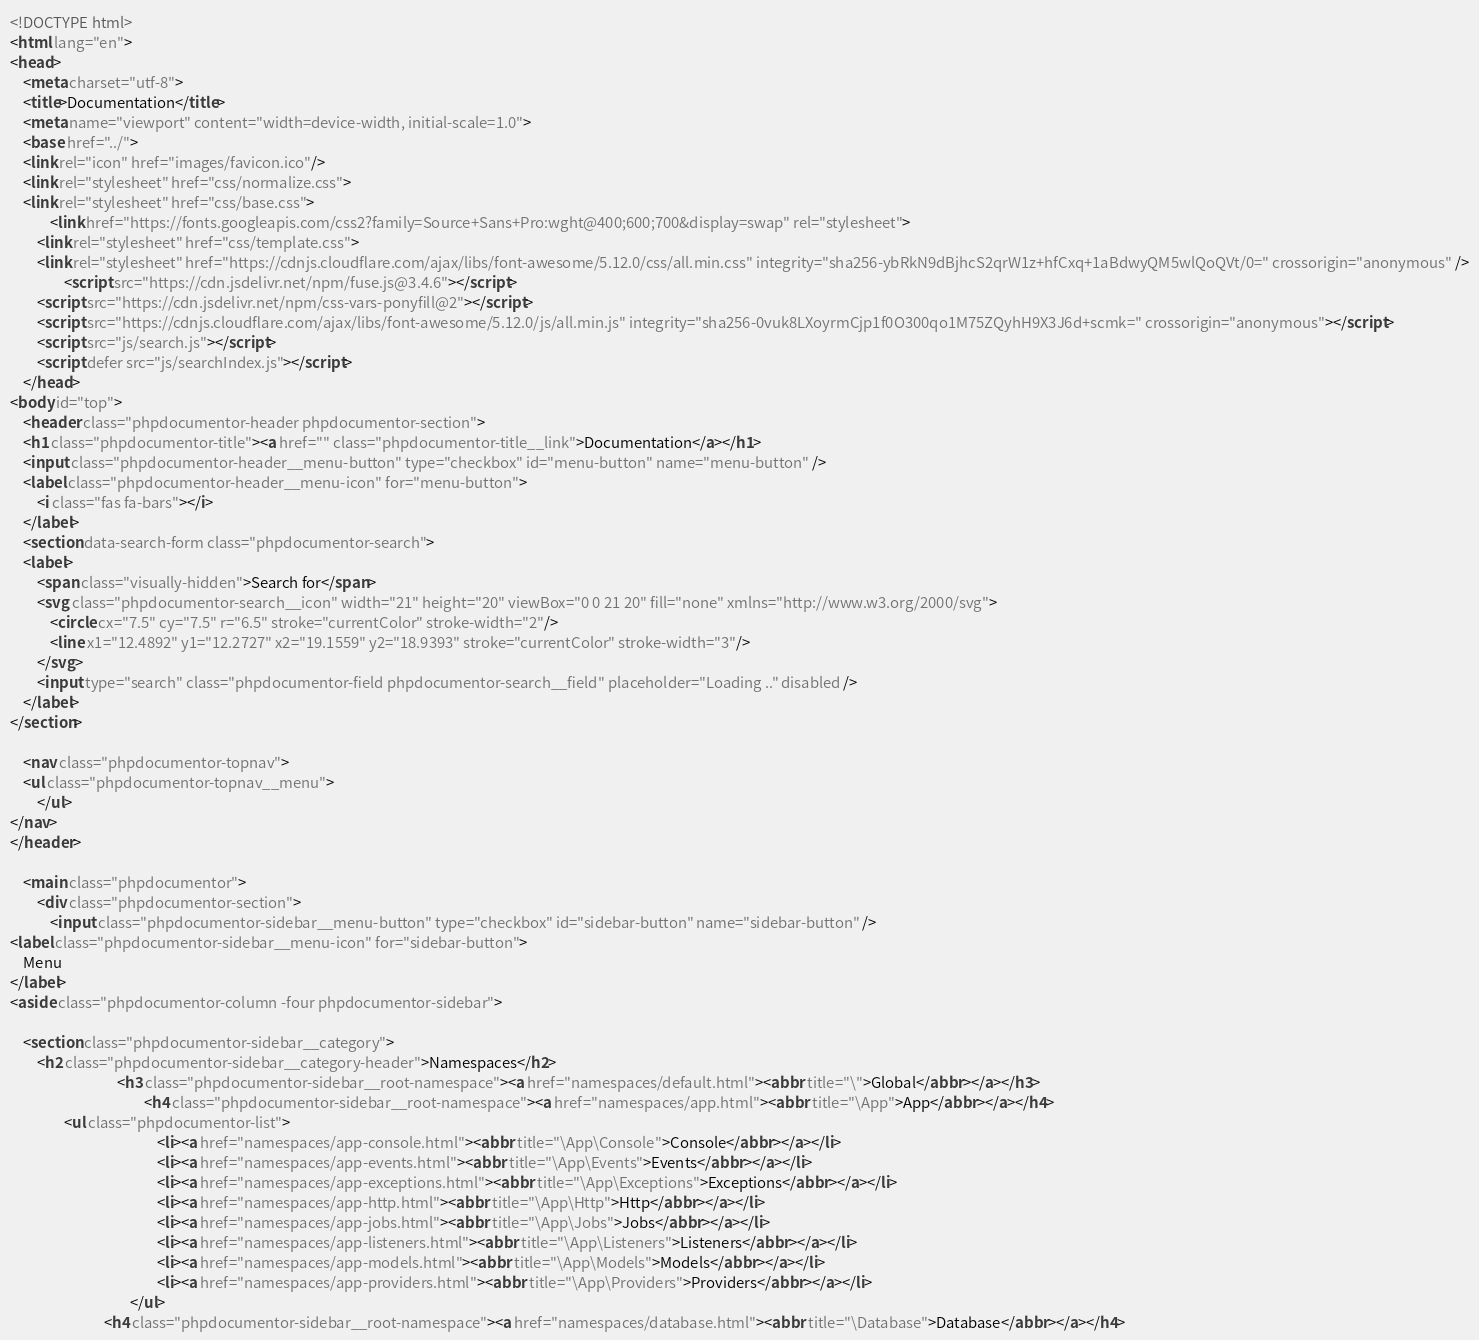Convert code to text. <code><loc_0><loc_0><loc_500><loc_500><_HTML_><!DOCTYPE html>
<html lang="en">
<head>
    <meta charset="utf-8">
    <title>Documentation</title>
    <meta name="viewport" content="width=device-width, initial-scale=1.0">
    <base href="../">
    <link rel="icon" href="images/favicon.ico"/>
    <link rel="stylesheet" href="css/normalize.css">
    <link rel="stylesheet" href="css/base.css">
            <link href="https://fonts.googleapis.com/css2?family=Source+Sans+Pro:wght@400;600;700&display=swap" rel="stylesheet">
        <link rel="stylesheet" href="css/template.css">
        <link rel="stylesheet" href="https://cdnjs.cloudflare.com/ajax/libs/font-awesome/5.12.0/css/all.min.css" integrity="sha256-ybRkN9dBjhcS2qrW1z+hfCxq+1aBdwyQM5wlQoQVt/0=" crossorigin="anonymous" />
                <script src="https://cdn.jsdelivr.net/npm/fuse.js@3.4.6"></script>
        <script src="https://cdn.jsdelivr.net/npm/css-vars-ponyfill@2"></script>
        <script src="https://cdnjs.cloudflare.com/ajax/libs/font-awesome/5.12.0/js/all.min.js" integrity="sha256-0vuk8LXoyrmCjp1f0O300qo1M75ZQyhH9X3J6d+scmk=" crossorigin="anonymous"></script>
        <script src="js/search.js"></script>
        <script defer src="js/searchIndex.js"></script>
    </head>
<body id="top">
    <header class="phpdocumentor-header phpdocumentor-section">
    <h1 class="phpdocumentor-title"><a href="" class="phpdocumentor-title__link">Documentation</a></h1>
    <input class="phpdocumentor-header__menu-button" type="checkbox" id="menu-button" name="menu-button" />
    <label class="phpdocumentor-header__menu-icon" for="menu-button">
        <i class="fas fa-bars"></i>
    </label>
    <section data-search-form class="phpdocumentor-search">
    <label>
        <span class="visually-hidden">Search for</span>
        <svg class="phpdocumentor-search__icon" width="21" height="20" viewBox="0 0 21 20" fill="none" xmlns="http://www.w3.org/2000/svg">
            <circle cx="7.5" cy="7.5" r="6.5" stroke="currentColor" stroke-width="2"/>
            <line x1="12.4892" y1="12.2727" x2="19.1559" y2="18.9393" stroke="currentColor" stroke-width="3"/>
        </svg>
        <input type="search" class="phpdocumentor-field phpdocumentor-search__field" placeholder="Loading .." disabled />
    </label>
</section>

    <nav class="phpdocumentor-topnav">
    <ul class="phpdocumentor-topnav__menu">
        </ul>
</nav>
</header>

    <main class="phpdocumentor">
        <div class="phpdocumentor-section">
            <input class="phpdocumentor-sidebar__menu-button" type="checkbox" id="sidebar-button" name="sidebar-button" />
<label class="phpdocumentor-sidebar__menu-icon" for="sidebar-button">
    Menu
</label>
<aside class="phpdocumentor-column -four phpdocumentor-sidebar">
    
    <section class="phpdocumentor-sidebar__category">
        <h2 class="phpdocumentor-sidebar__category-header">Namespaces</h2>
                                <h3 class="phpdocumentor-sidebar__root-namespace"><a href="namespaces/default.html"><abbr title="\">Global</abbr></a></h3>
                                        <h4 class="phpdocumentor-sidebar__root-namespace"><a href="namespaces/app.html"><abbr title="\App">App</abbr></a></h4>
                <ul class="phpdocumentor-list">
                                            <li><a href="namespaces/app-console.html"><abbr title="\App\Console">Console</abbr></a></li>
                                            <li><a href="namespaces/app-events.html"><abbr title="\App\Events">Events</abbr></a></li>
                                            <li><a href="namespaces/app-exceptions.html"><abbr title="\App\Exceptions">Exceptions</abbr></a></li>
                                            <li><a href="namespaces/app-http.html"><abbr title="\App\Http">Http</abbr></a></li>
                                            <li><a href="namespaces/app-jobs.html"><abbr title="\App\Jobs">Jobs</abbr></a></li>
                                            <li><a href="namespaces/app-listeners.html"><abbr title="\App\Listeners">Listeners</abbr></a></li>
                                            <li><a href="namespaces/app-models.html"><abbr title="\App\Models">Models</abbr></a></li>
                                            <li><a href="namespaces/app-providers.html"><abbr title="\App\Providers">Providers</abbr></a></li>
                                    </ul>
                            <h4 class="phpdocumentor-sidebar__root-namespace"><a href="namespaces/database.html"><abbr title="\Database">Database</abbr></a></h4></code> 